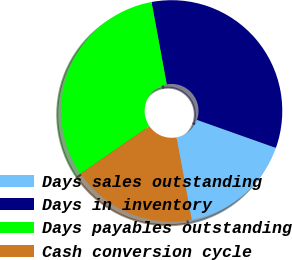Convert chart to OTSL. <chart><loc_0><loc_0><loc_500><loc_500><pie_chart><fcel>Days sales outstanding<fcel>Days in inventory<fcel>Days payables outstanding<fcel>Cash conversion cycle<nl><fcel>16.67%<fcel>33.33%<fcel>31.71%<fcel>18.29%<nl></chart> 